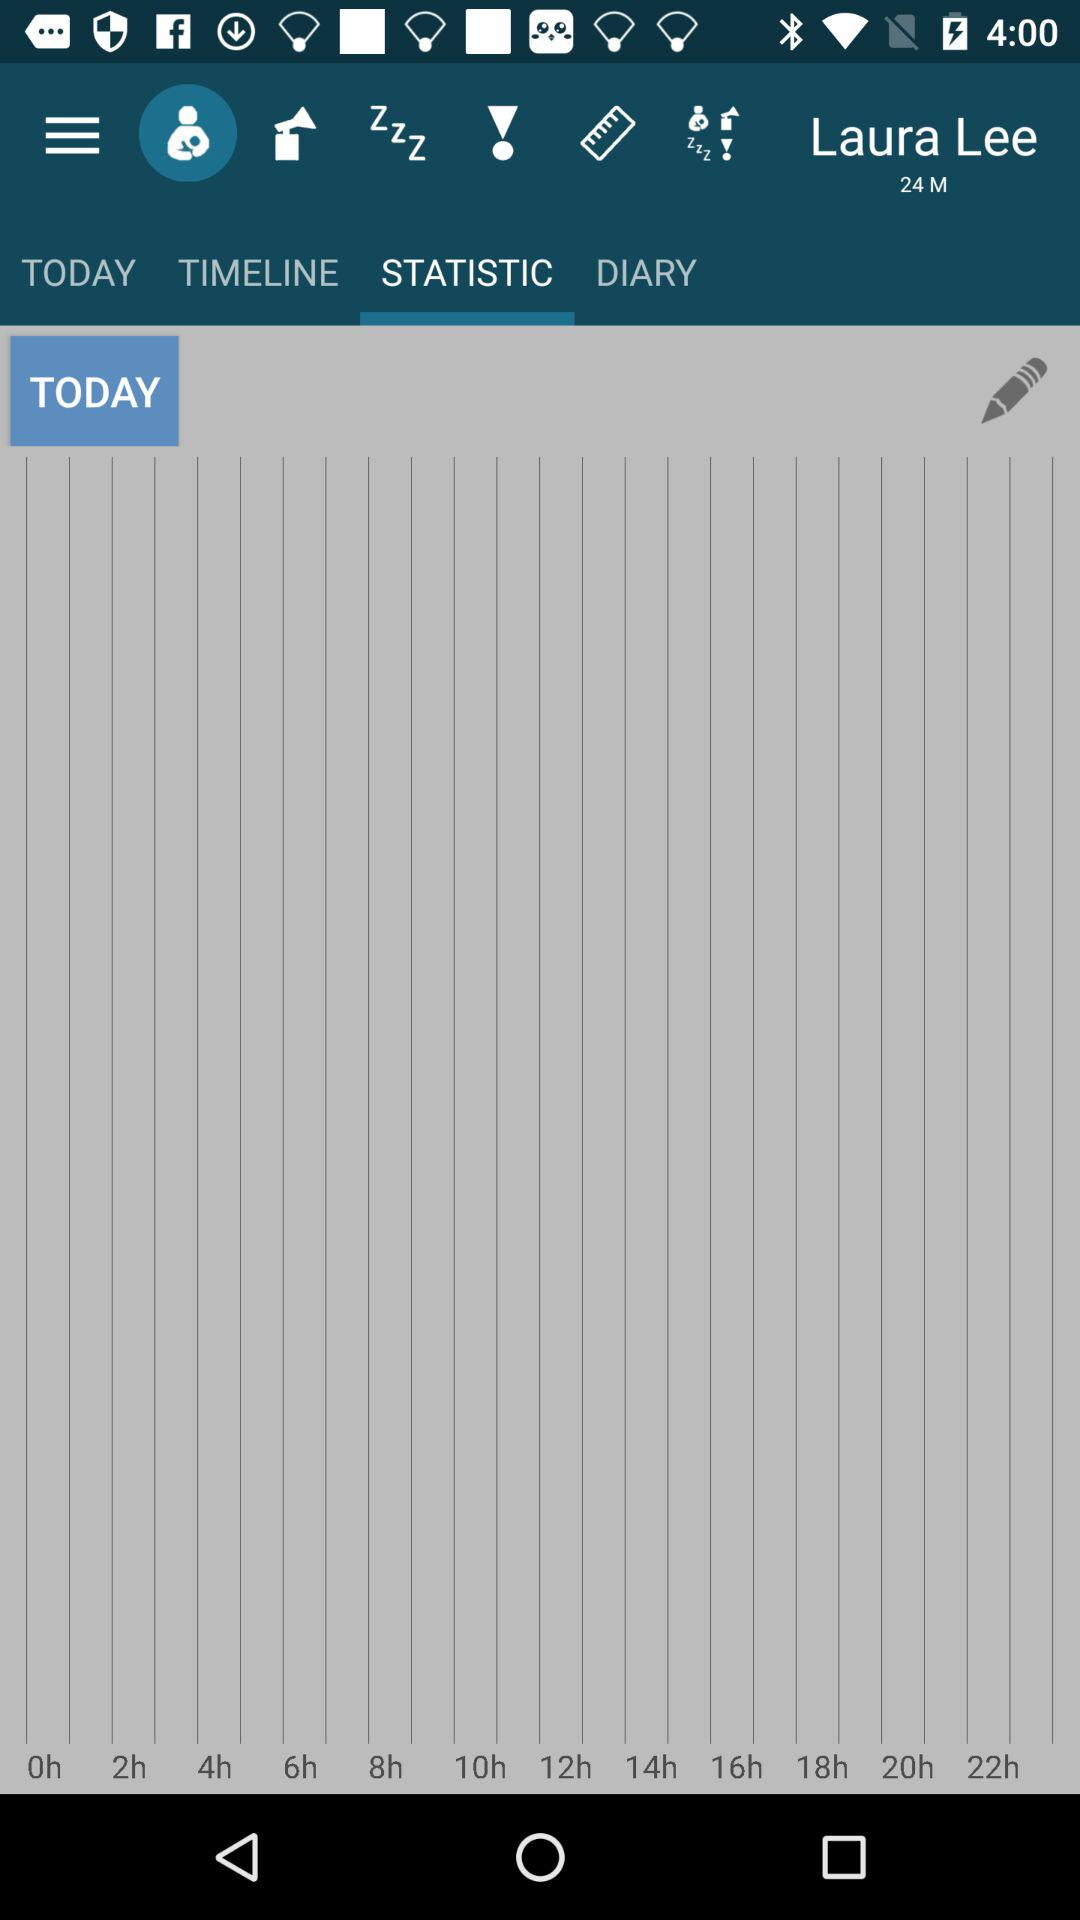What is the age of the person? The age of the person is 24 months. 